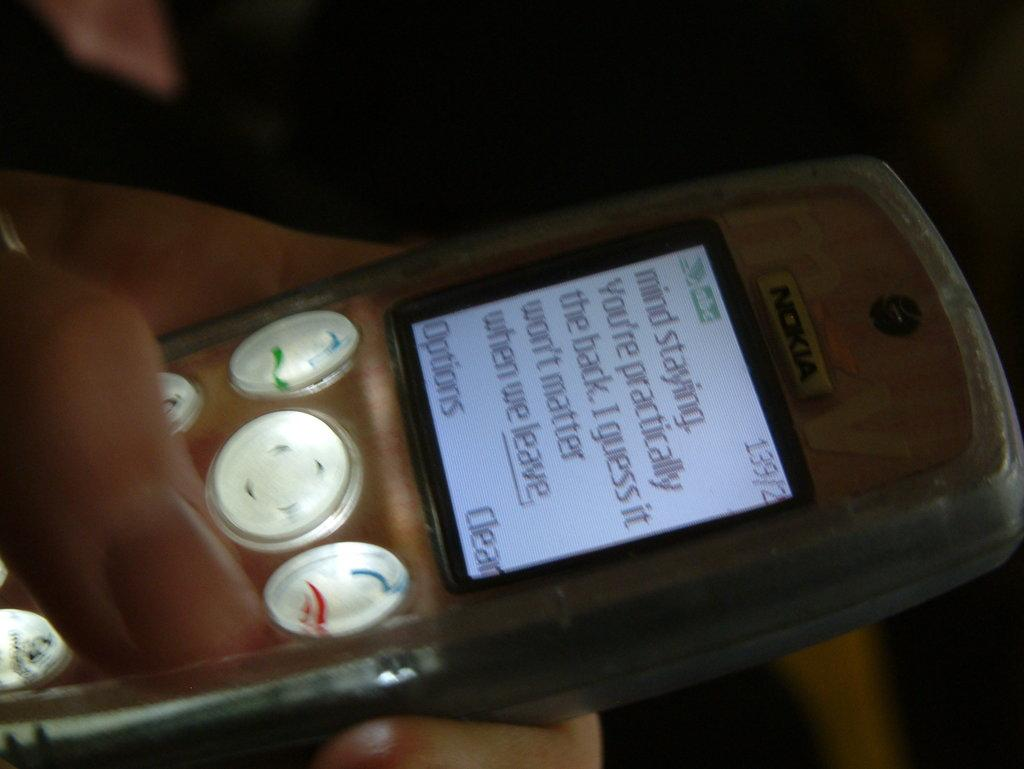Provide a one-sentence caption for the provided image. hand holding phone with text message displaying mind staying, you're practically the back i guess it won't matter when we leave. 